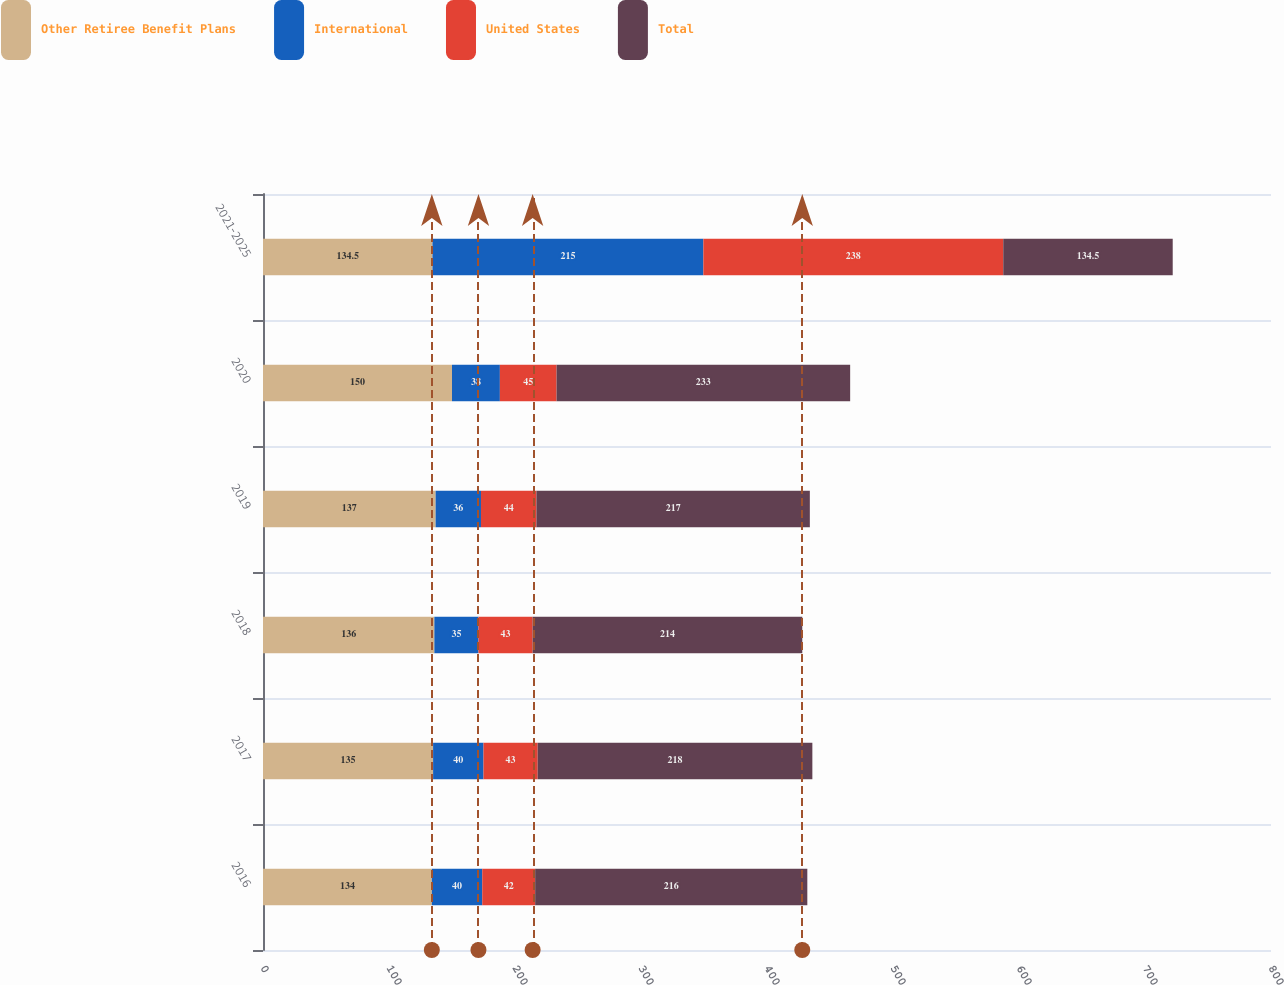Convert chart to OTSL. <chart><loc_0><loc_0><loc_500><loc_500><stacked_bar_chart><ecel><fcel>2016<fcel>2017<fcel>2018<fcel>2019<fcel>2020<fcel>2021-2025<nl><fcel>Other Retiree Benefit Plans<fcel>134<fcel>135<fcel>136<fcel>137<fcel>150<fcel>134.5<nl><fcel>International<fcel>40<fcel>40<fcel>35<fcel>36<fcel>38<fcel>215<nl><fcel>United States<fcel>42<fcel>43<fcel>43<fcel>44<fcel>45<fcel>238<nl><fcel>Total<fcel>216<fcel>218<fcel>214<fcel>217<fcel>233<fcel>134.5<nl></chart> 